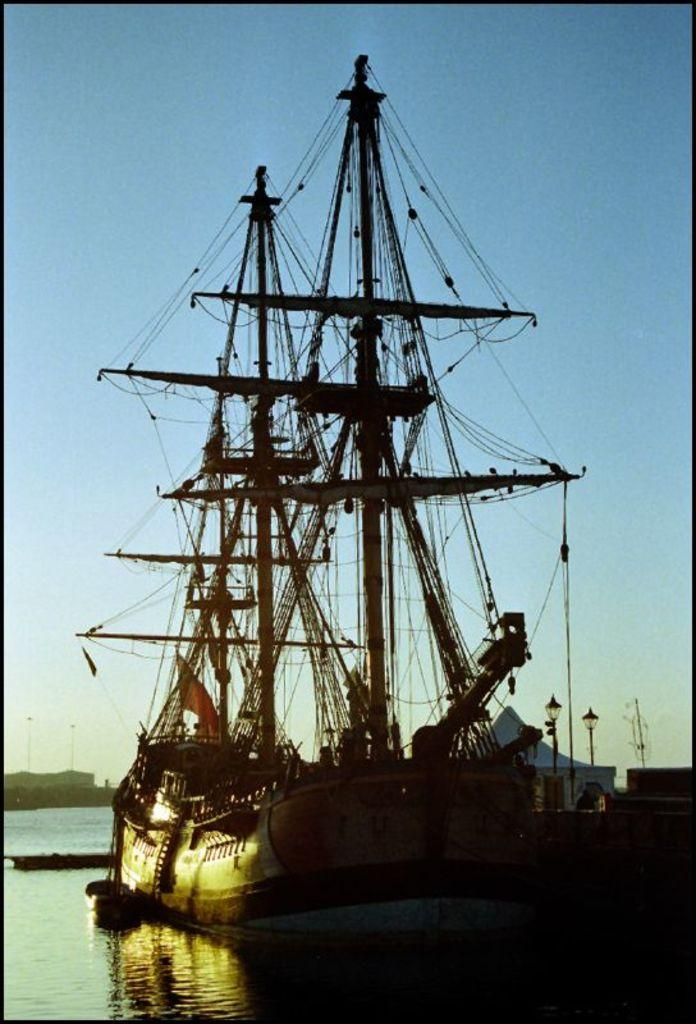What is the main subject of the image? The main subject of the image is a ship. What can be seen flying on the ship? There is a flag in the image. What structures are present on the ship? There are poles in the image. What type of material is present in the image? There is wire in the image. What can be seen in the background of the image? There are light-poles and water visible in the background of the image. What is the color of the sky in the image? The sky is blue and white in color. What is the rate at which the scarf is being knitted in the image? There is no scarf present in the image, so it is not possible to determine the rate at which it might be knitted. 